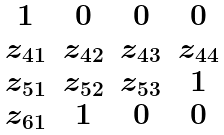<formula> <loc_0><loc_0><loc_500><loc_500>\begin{matrix} 1 & 0 & 0 & 0 \\ z _ { 4 1 } & z _ { 4 2 } & z _ { 4 3 } & z _ { 4 4 } \\ z _ { 5 1 } & z _ { 5 2 } & z _ { 5 3 } & 1 \\ z _ { 6 1 } & 1 & 0 & 0 \end{matrix}</formula> 